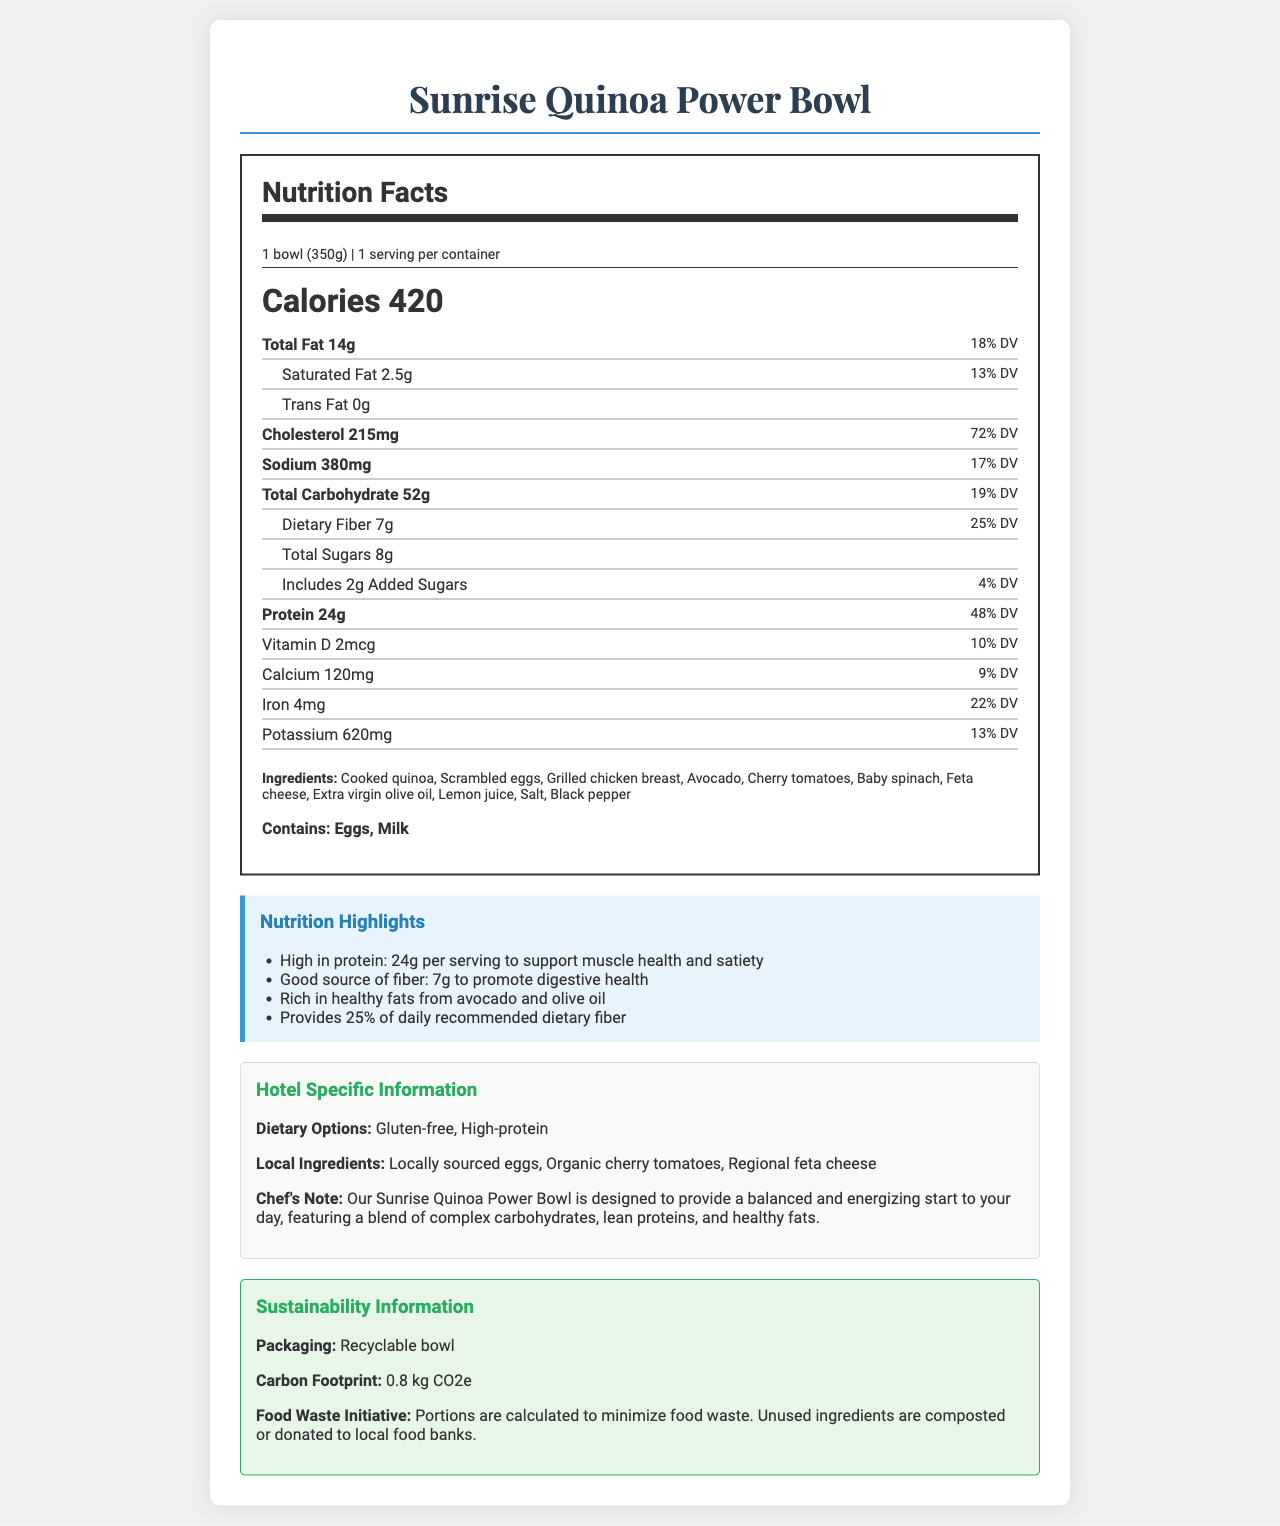what is the calorie content of the Sunrise Quinoa Power Bowl? The calorie content is highlighted as "Calories 420" in the Nutrition Facts section of the document.
Answer: 420 calories How much protein does one serving of the Sunrise Quinoa Power Bowl provide? The protein amount is listed as "Protein 24g" in the Nutrition Facts section.
Answer: 24g What is the serving size of the Sunrise Quinoa Power Bowl? The serving size is specified as "1 bowl (350g)" in the serving information section of the Nutrition Facts.
Answer: 1 bowl (350g) What percentage of the daily recommended value of dietary fiber does one serving provide? The daily value percentage for dietary fiber is shown as "Dietary Fiber 7g 25% DV" in the Nutrition Facts.
Answer: 25% Which ingredients in the Sunrise Quinoa Power Bowl are allergens? The allergens section lists "Contains: Eggs, Milk".
Answer: Eggs, Milk What is the total fat content including its daily value percentage? A. 10g, 15% B. 12g, 20% C. 14g, 18% D. 15g, 22% The total fat content is provided as "Total Fat 14g" with a daily value of "18% DV".
Answer: C What is the carbon footprint of the Sunrise Quinoa Power Bowl? A. 0.5 kg CO2e B. 0.8 kg CO2e C. 1.0 kg CO2e D. 1.2 kg CO2e The sustainability information specifies a "carbon footprint: 0.8 kg CO2e".
Answer: B Does the Sunrise Quinoa Power Bowl contain trans fat? The Nutrition Facts lists "Trans Fat 0g", indicating it does not contain trans fat.
Answer: No Is this dish suitable for someone looking for a gluten-free option? The dietary options section mentions that it is "Gluten-free".
Answer: Yes Summarize the main idea of the document. The document provides a comprehensive overview of the nutritional content, ingredients, dietary options, and sustainability efforts related to the Sunrise Quinoa Power Bowl offered by the hotel.
Answer: The Sunrise Quinoa Power Bowl is a high-protein, gluten-free breakfast dish offered by the hotel. It contains 420 calories and 24 grams of protein per serving. The dish includes local and organic ingredients, and it comes with detailed nutritional information. The hotel's sustainability initiatives are also highlighted, including recyclable packaging and efforts to minimize food waste. What are the sources of the healthy fats in the Sunrise Quinoa Power Bowl? The nutrition highlights section mentions that the dish is "rich in healthy fats from avocado and olive oil".
Answer: Avocado, Extra virgin olive oil How much daily value percentage of calcium does the dish provide? The Nutrition Facts section lists the calcium content as "Calcium 120mg 9% DV".
Answer: 9% What is the chef's intention behind creating the Sunrise Quinoa Power Bowl? The chef's note in the hotel-specific information section states the purpose of the dish.
Answer: To provide a balanced and energizing start to the day, featuring a blend of complex carbohydrates, lean proteins, and healthy fats. What is the foo sustainability initiative mentioned in the document? The sustainability section explains the food waste initiative as minimizing food waste and composting or donating unused ingredients.
Answer: Portions are calculated to minimize food waste. Unused ingredients are composted or donated to local food banks. Does the document provide the price of the Sunrise Quinoa Power Bowl? The document does not include any information regarding the price of the dish.
Answer: Cannot be determined 